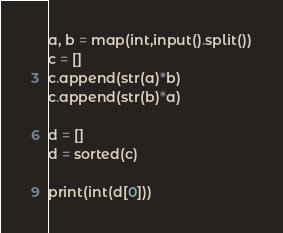Convert code to text. <code><loc_0><loc_0><loc_500><loc_500><_Python_>a, b = map(int,input().split())
c = []
c.append(str(a)*b)
c.append(str(b)*a)

d = []
d = sorted(c)

print(int(d[0]))

</code> 